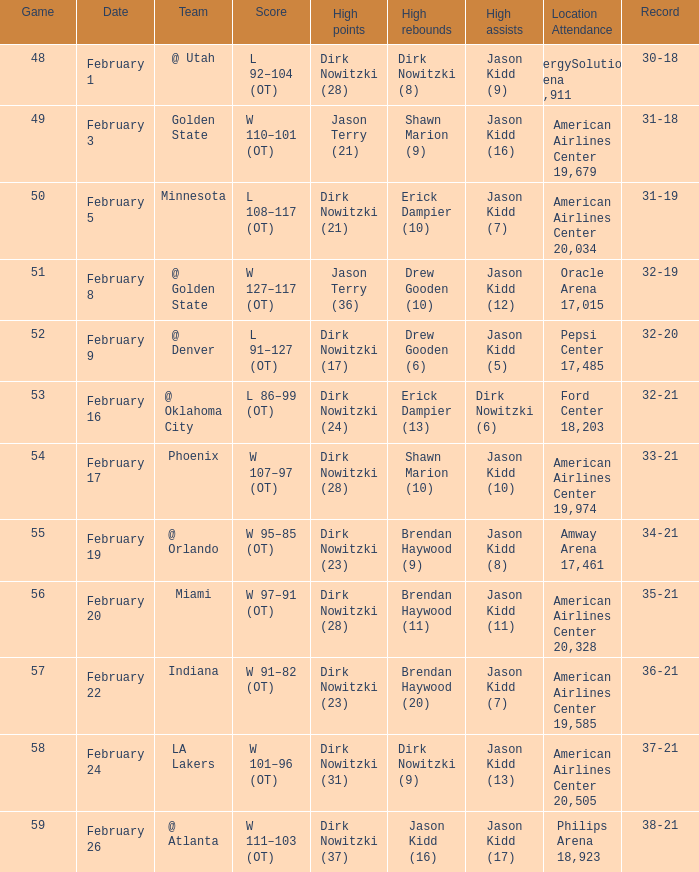When did the Mavericks have a record of 32-19? February 8. 